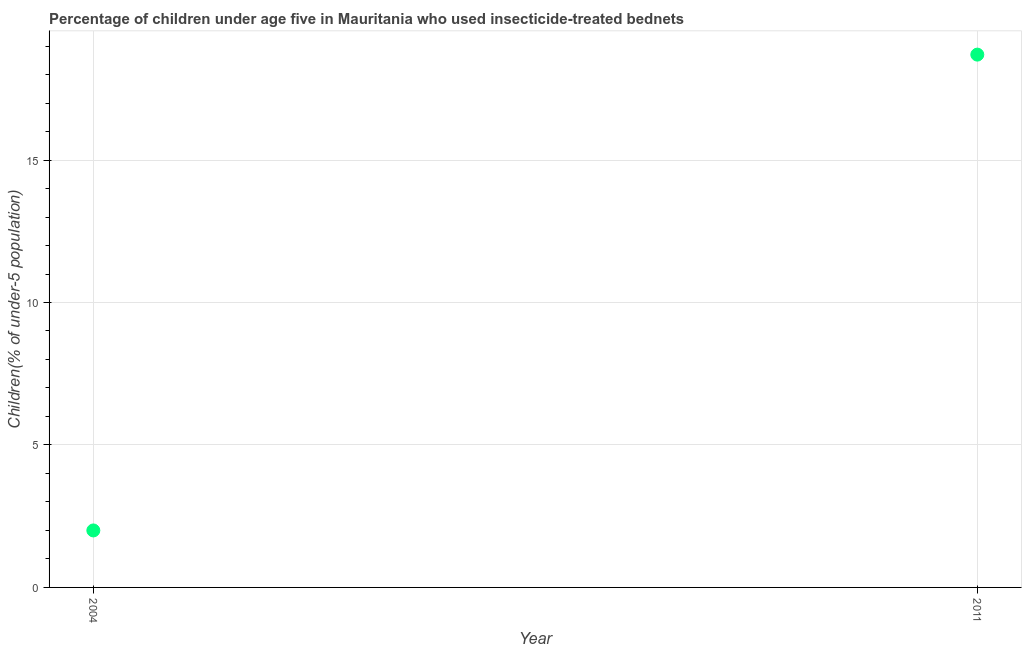In which year was the percentage of children who use of insecticide-treated bed nets maximum?
Keep it short and to the point. 2011. What is the sum of the percentage of children who use of insecticide-treated bed nets?
Ensure brevity in your answer.  20.7. What is the difference between the percentage of children who use of insecticide-treated bed nets in 2004 and 2011?
Offer a terse response. -16.7. What is the average percentage of children who use of insecticide-treated bed nets per year?
Your response must be concise. 10.35. What is the median percentage of children who use of insecticide-treated bed nets?
Provide a short and direct response. 10.35. Do a majority of the years between 2004 and 2011 (inclusive) have percentage of children who use of insecticide-treated bed nets greater than 4 %?
Make the answer very short. No. What is the ratio of the percentage of children who use of insecticide-treated bed nets in 2004 to that in 2011?
Your response must be concise. 0.11. Is the percentage of children who use of insecticide-treated bed nets in 2004 less than that in 2011?
Give a very brief answer. Yes. Does the percentage of children who use of insecticide-treated bed nets monotonically increase over the years?
Your answer should be compact. Yes. How many dotlines are there?
Your response must be concise. 1. How many years are there in the graph?
Your response must be concise. 2. What is the difference between two consecutive major ticks on the Y-axis?
Your answer should be very brief. 5. Are the values on the major ticks of Y-axis written in scientific E-notation?
Your response must be concise. No. What is the title of the graph?
Keep it short and to the point. Percentage of children under age five in Mauritania who used insecticide-treated bednets. What is the label or title of the Y-axis?
Offer a very short reply. Children(% of under-5 population). What is the Children(% of under-5 population) in 2004?
Give a very brief answer. 2. What is the Children(% of under-5 population) in 2011?
Offer a very short reply. 18.7. What is the difference between the Children(% of under-5 population) in 2004 and 2011?
Offer a terse response. -16.7. What is the ratio of the Children(% of under-5 population) in 2004 to that in 2011?
Provide a short and direct response. 0.11. 